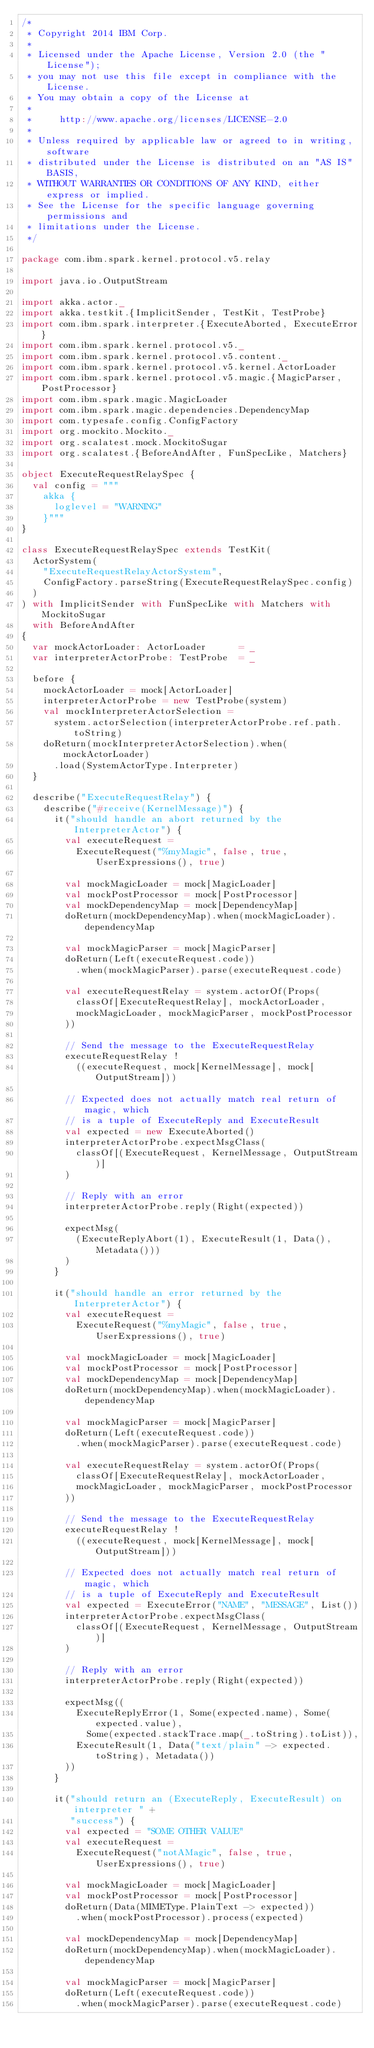<code> <loc_0><loc_0><loc_500><loc_500><_Scala_>/*
 * Copyright 2014 IBM Corp.
 *
 * Licensed under the Apache License, Version 2.0 (the "License");
 * you may not use this file except in compliance with the License.
 * You may obtain a copy of the License at
 *
 *     http://www.apache.org/licenses/LICENSE-2.0
 *
 * Unless required by applicable law or agreed to in writing, software
 * distributed under the License is distributed on an "AS IS" BASIS,
 * WITHOUT WARRANTIES OR CONDITIONS OF ANY KIND, either express or implied.
 * See the License for the specific language governing permissions and
 * limitations under the License.
 */

package com.ibm.spark.kernel.protocol.v5.relay

import java.io.OutputStream

import akka.actor._
import akka.testkit.{ImplicitSender, TestKit, TestProbe}
import com.ibm.spark.interpreter.{ExecuteAborted, ExecuteError}
import com.ibm.spark.kernel.protocol.v5._
import com.ibm.spark.kernel.protocol.v5.content._
import com.ibm.spark.kernel.protocol.v5.kernel.ActorLoader
import com.ibm.spark.kernel.protocol.v5.magic.{MagicParser, PostProcessor}
import com.ibm.spark.magic.MagicLoader
import com.ibm.spark.magic.dependencies.DependencyMap
import com.typesafe.config.ConfigFactory
import org.mockito.Mockito._
import org.scalatest.mock.MockitoSugar
import org.scalatest.{BeforeAndAfter, FunSpecLike, Matchers}

object ExecuteRequestRelaySpec {
  val config = """
    akka {
      loglevel = "WARNING"
    }"""
}

class ExecuteRequestRelaySpec extends TestKit(
  ActorSystem(
    "ExecuteRequestRelayActorSystem",
    ConfigFactory.parseString(ExecuteRequestRelaySpec.config)
  )
) with ImplicitSender with FunSpecLike with Matchers with MockitoSugar
  with BeforeAndAfter
{
  var mockActorLoader: ActorLoader      = _
  var interpreterActorProbe: TestProbe  = _

  before {
    mockActorLoader = mock[ActorLoader]
    interpreterActorProbe = new TestProbe(system)
    val mockInterpreterActorSelection =
      system.actorSelection(interpreterActorProbe.ref.path.toString)
    doReturn(mockInterpreterActorSelection).when(mockActorLoader)
      .load(SystemActorType.Interpreter)
  }

  describe("ExecuteRequestRelay") {
    describe("#receive(KernelMessage)") {
      it("should handle an abort returned by the InterpreterActor") {
        val executeRequest =
          ExecuteRequest("%myMagic", false, true, UserExpressions(), true)

        val mockMagicLoader = mock[MagicLoader]
        val mockPostProcessor = mock[PostProcessor]
        val mockDependencyMap = mock[DependencyMap]
        doReturn(mockDependencyMap).when(mockMagicLoader).dependencyMap

        val mockMagicParser = mock[MagicParser]
        doReturn(Left(executeRequest.code))
          .when(mockMagicParser).parse(executeRequest.code)

        val executeRequestRelay = system.actorOf(Props(
          classOf[ExecuteRequestRelay], mockActorLoader,
          mockMagicLoader, mockMagicParser, mockPostProcessor
        ))

        // Send the message to the ExecuteRequestRelay
        executeRequestRelay !
          ((executeRequest, mock[KernelMessage], mock[OutputStream]))

        // Expected does not actually match real return of magic, which
        // is a tuple of ExecuteReply and ExecuteResult
        val expected = new ExecuteAborted()
        interpreterActorProbe.expectMsgClass(
          classOf[(ExecuteRequest, KernelMessage, OutputStream)]
        )

        // Reply with an error
        interpreterActorProbe.reply(Right(expected))

        expectMsg(
          (ExecuteReplyAbort(1), ExecuteResult(1, Data(), Metadata()))
        )
      }

      it("should handle an error returned by the InterpreterActor") {
        val executeRequest =
          ExecuteRequest("%myMagic", false, true, UserExpressions(), true)

        val mockMagicLoader = mock[MagicLoader]
        val mockPostProcessor = mock[PostProcessor]
        val mockDependencyMap = mock[DependencyMap]
        doReturn(mockDependencyMap).when(mockMagicLoader).dependencyMap

        val mockMagicParser = mock[MagicParser]
        doReturn(Left(executeRequest.code))
          .when(mockMagicParser).parse(executeRequest.code)

        val executeRequestRelay = system.actorOf(Props(
          classOf[ExecuteRequestRelay], mockActorLoader,
          mockMagicLoader, mockMagicParser, mockPostProcessor
        ))

        // Send the message to the ExecuteRequestRelay
        executeRequestRelay !
          ((executeRequest, mock[KernelMessage], mock[OutputStream]))

        // Expected does not actually match real return of magic, which
        // is a tuple of ExecuteReply and ExecuteResult
        val expected = ExecuteError("NAME", "MESSAGE", List())
        interpreterActorProbe.expectMsgClass(
          classOf[(ExecuteRequest, KernelMessage, OutputStream)]
        )

        // Reply with an error
        interpreterActorProbe.reply(Right(expected))

        expectMsg((
          ExecuteReplyError(1, Some(expected.name), Some(expected.value),
            Some(expected.stackTrace.map(_.toString).toList)),
          ExecuteResult(1, Data("text/plain" -> expected.toString), Metadata())
        ))
      }

      it("should return an (ExecuteReply, ExecuteResult) on interpreter " +
         "success") {
        val expected = "SOME OTHER VALUE"
        val executeRequest =
          ExecuteRequest("notAMagic", false, true, UserExpressions(), true)

        val mockMagicLoader = mock[MagicLoader]
        val mockPostProcessor = mock[PostProcessor]
        doReturn(Data(MIMEType.PlainText -> expected))
          .when(mockPostProcessor).process(expected)

        val mockDependencyMap = mock[DependencyMap]
        doReturn(mockDependencyMap).when(mockMagicLoader).dependencyMap

        val mockMagicParser = mock[MagicParser]
        doReturn(Left(executeRequest.code))
          .when(mockMagicParser).parse(executeRequest.code)
</code> 